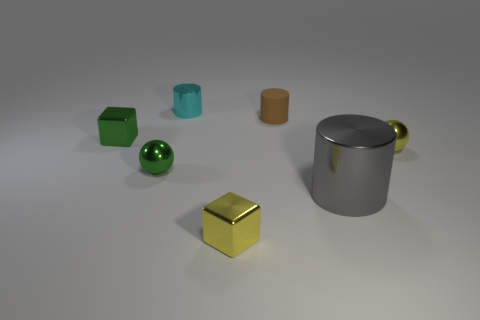Add 2 tiny blue cylinders. How many objects exist? 9 Subtract all cubes. How many objects are left? 5 Subtract 0 red balls. How many objects are left? 7 Subtract all purple metallic spheres. Subtract all cubes. How many objects are left? 5 Add 7 spheres. How many spheres are left? 9 Add 4 cubes. How many cubes exist? 6 